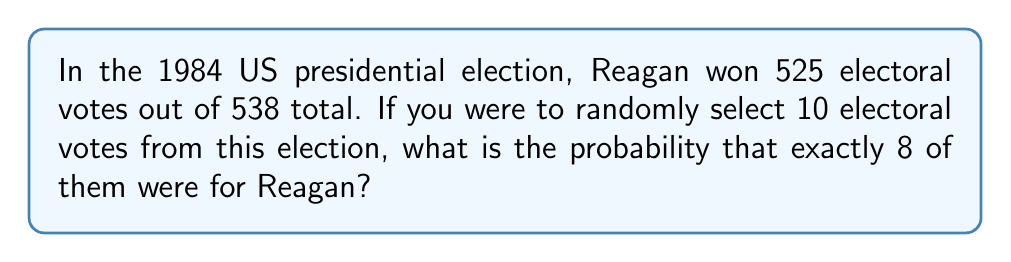Give your solution to this math problem. To solve this problem, we need to use the hypergeometric distribution, which is appropriate for sampling without replacement from a finite population.

Let's break it down step-by-step:

1) We have:
   - Total electoral votes: 538
   - Reagan's electoral votes: 525
   - Sample size: 10
   - Desired number of Reagan votes in sample: 8

2) The probability is given by the hypergeometric distribution formula:

   $$P(X=k) = \frac{\binom{K}{k} \binom{N-K}{n-k}}{\binom{N}{n}}$$

   Where:
   $N$ = total population size (538)
   $K$ = number of success states in the population (525)
   $n$ = number of draws (10)
   $k$ = number of observed successes (8)

3) Plugging in our values:

   $$P(X=8) = \frac{\binom{525}{8} \binom{538-525}{10-8}}{\binom{538}{10}}$$

4) Simplify:

   $$P(X=8) = \frac{\binom{525}{8} \binom{13}{2}}{\binom{538}{10}}$$

5) Calculate the combinations:
   
   $$P(X=8) = \frac{(3.8965 \times 10^{16}) \times 78}{2.2451 \times 10^{18}}$$

6) Divide:

   $$P(X=8) = 0.1355$$

Thus, the probability is approximately 0.1355 or 13.55%.
Answer: 0.1355 